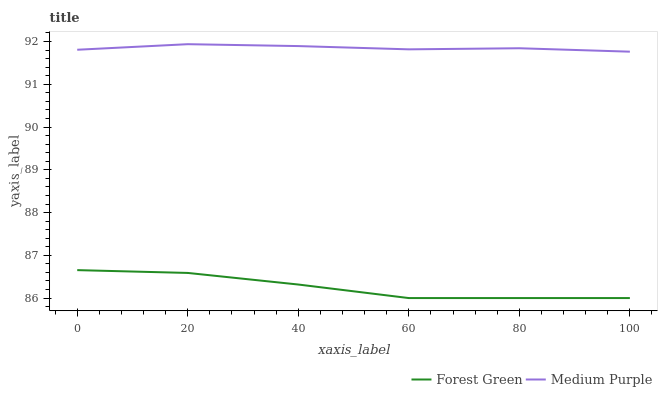Does Forest Green have the minimum area under the curve?
Answer yes or no. Yes. Does Medium Purple have the maximum area under the curve?
Answer yes or no. Yes. Does Forest Green have the maximum area under the curve?
Answer yes or no. No. Is Medium Purple the smoothest?
Answer yes or no. Yes. Is Forest Green the roughest?
Answer yes or no. Yes. Is Forest Green the smoothest?
Answer yes or no. No. Does Forest Green have the lowest value?
Answer yes or no. Yes. Does Medium Purple have the highest value?
Answer yes or no. Yes. Does Forest Green have the highest value?
Answer yes or no. No. Is Forest Green less than Medium Purple?
Answer yes or no. Yes. Is Medium Purple greater than Forest Green?
Answer yes or no. Yes. Does Forest Green intersect Medium Purple?
Answer yes or no. No. 